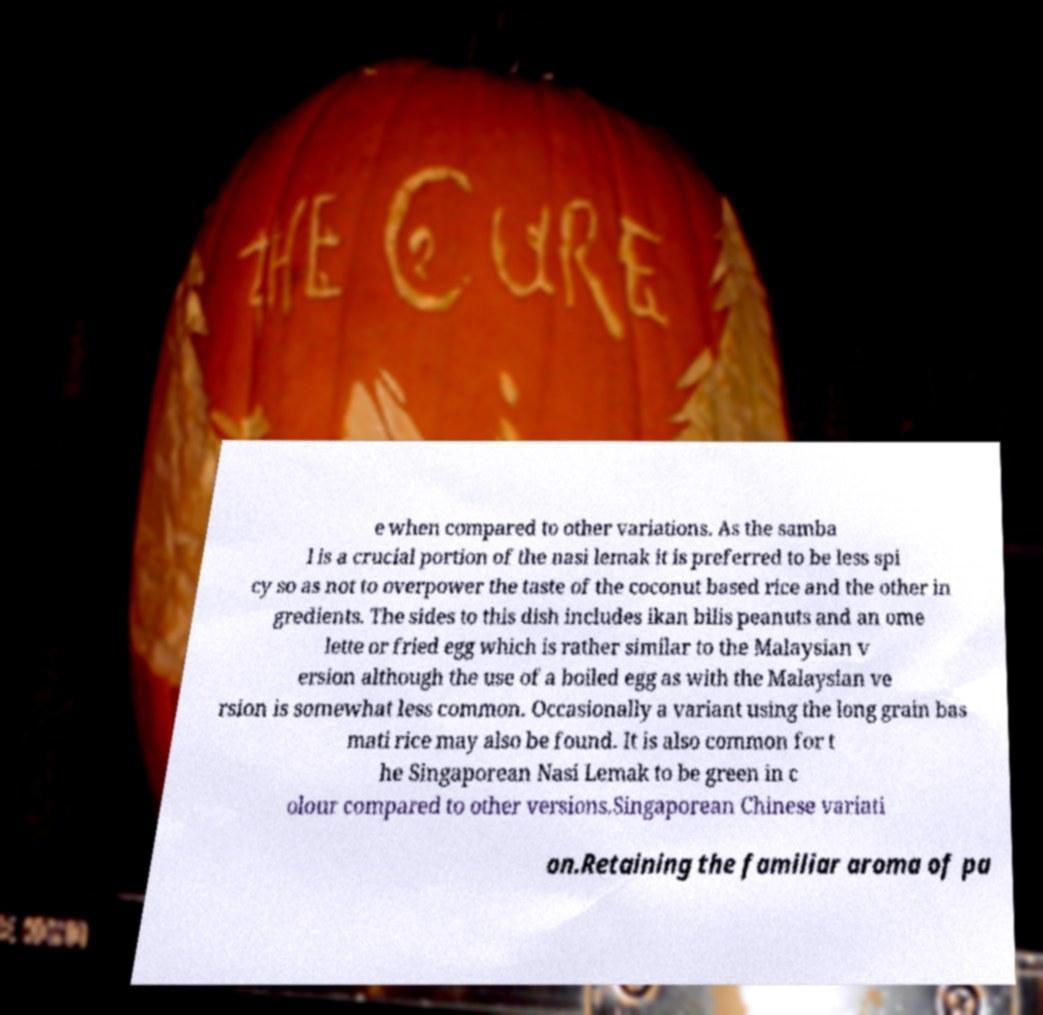Could you assist in decoding the text presented in this image and type it out clearly? e when compared to other variations. As the samba l is a crucial portion of the nasi lemak it is preferred to be less spi cy so as not to overpower the taste of the coconut based rice and the other in gredients. The sides to this dish includes ikan bilis peanuts and an ome lette or fried egg which is rather similar to the Malaysian v ersion although the use of a boiled egg as with the Malaysian ve rsion is somewhat less common. Occasionally a variant using the long grain bas mati rice may also be found. It is also common for t he Singaporean Nasi Lemak to be green in c olour compared to other versions.Singaporean Chinese variati on.Retaining the familiar aroma of pa 